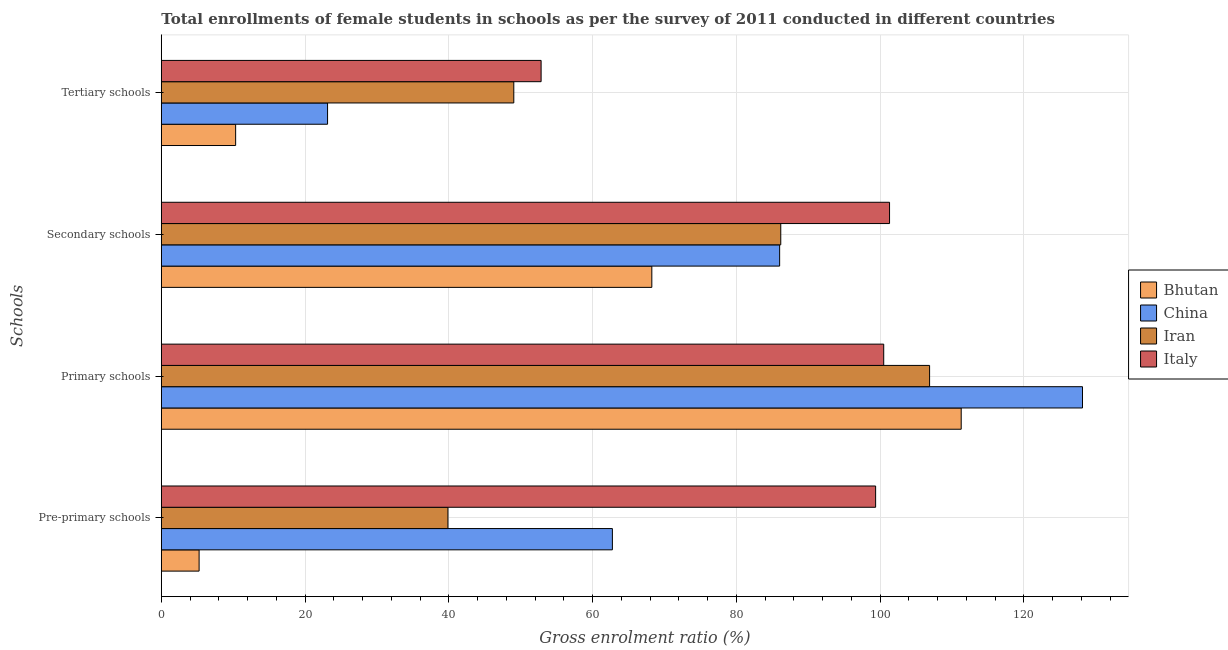Are the number of bars per tick equal to the number of legend labels?
Your response must be concise. Yes. Are the number of bars on each tick of the Y-axis equal?
Give a very brief answer. Yes. What is the label of the 4th group of bars from the top?
Keep it short and to the point. Pre-primary schools. What is the gross enrolment ratio(female) in primary schools in Bhutan?
Ensure brevity in your answer.  111.28. Across all countries, what is the maximum gross enrolment ratio(female) in tertiary schools?
Offer a terse response. 52.84. Across all countries, what is the minimum gross enrolment ratio(female) in primary schools?
Provide a short and direct response. 100.5. In which country was the gross enrolment ratio(female) in secondary schools maximum?
Offer a very short reply. Italy. In which country was the gross enrolment ratio(female) in secondary schools minimum?
Offer a very short reply. Bhutan. What is the total gross enrolment ratio(female) in secondary schools in the graph?
Make the answer very short. 341.76. What is the difference between the gross enrolment ratio(female) in tertiary schools in Iran and that in Bhutan?
Your answer should be very brief. 38.7. What is the difference between the gross enrolment ratio(female) in secondary schools in Iran and the gross enrolment ratio(female) in pre-primary schools in Italy?
Give a very brief answer. -13.2. What is the average gross enrolment ratio(female) in secondary schools per country?
Keep it short and to the point. 85.44. What is the difference between the gross enrolment ratio(female) in pre-primary schools and gross enrolment ratio(female) in primary schools in China?
Offer a terse response. -65.4. What is the ratio of the gross enrolment ratio(female) in pre-primary schools in China to that in Bhutan?
Ensure brevity in your answer.  11.93. Is the difference between the gross enrolment ratio(female) in secondary schools in China and Bhutan greater than the difference between the gross enrolment ratio(female) in pre-primary schools in China and Bhutan?
Provide a short and direct response. No. What is the difference between the highest and the second highest gross enrolment ratio(female) in pre-primary schools?
Ensure brevity in your answer.  36.62. What is the difference between the highest and the lowest gross enrolment ratio(female) in pre-primary schools?
Keep it short and to the point. 94.12. What does the 1st bar from the top in Tertiary schools represents?
Your answer should be very brief. Italy. What does the 1st bar from the bottom in Primary schools represents?
Provide a succinct answer. Bhutan. Is it the case that in every country, the sum of the gross enrolment ratio(female) in pre-primary schools and gross enrolment ratio(female) in primary schools is greater than the gross enrolment ratio(female) in secondary schools?
Ensure brevity in your answer.  Yes. How many bars are there?
Provide a succinct answer. 16. Are all the bars in the graph horizontal?
Keep it short and to the point. Yes. What is the difference between two consecutive major ticks on the X-axis?
Provide a succinct answer. 20. Are the values on the major ticks of X-axis written in scientific E-notation?
Provide a short and direct response. No. How many legend labels are there?
Your answer should be very brief. 4. What is the title of the graph?
Your answer should be very brief. Total enrollments of female students in schools as per the survey of 2011 conducted in different countries. What is the label or title of the X-axis?
Your answer should be very brief. Gross enrolment ratio (%). What is the label or title of the Y-axis?
Provide a short and direct response. Schools. What is the Gross enrolment ratio (%) in Bhutan in Pre-primary schools?
Give a very brief answer. 5.26. What is the Gross enrolment ratio (%) of China in Pre-primary schools?
Make the answer very short. 62.76. What is the Gross enrolment ratio (%) of Iran in Pre-primary schools?
Provide a succinct answer. 39.88. What is the Gross enrolment ratio (%) in Italy in Pre-primary schools?
Your response must be concise. 99.38. What is the Gross enrolment ratio (%) in Bhutan in Primary schools?
Make the answer very short. 111.28. What is the Gross enrolment ratio (%) of China in Primary schools?
Ensure brevity in your answer.  128.16. What is the Gross enrolment ratio (%) in Iran in Primary schools?
Ensure brevity in your answer.  106.89. What is the Gross enrolment ratio (%) of Italy in Primary schools?
Provide a succinct answer. 100.5. What is the Gross enrolment ratio (%) in Bhutan in Secondary schools?
Ensure brevity in your answer.  68.24. What is the Gross enrolment ratio (%) in China in Secondary schools?
Keep it short and to the point. 86.02. What is the Gross enrolment ratio (%) of Iran in Secondary schools?
Provide a succinct answer. 86.18. What is the Gross enrolment ratio (%) in Italy in Secondary schools?
Offer a terse response. 101.32. What is the Gross enrolment ratio (%) in Bhutan in Tertiary schools?
Provide a short and direct response. 10.34. What is the Gross enrolment ratio (%) in China in Tertiary schools?
Provide a succinct answer. 23.13. What is the Gross enrolment ratio (%) in Iran in Tertiary schools?
Give a very brief answer. 49.04. What is the Gross enrolment ratio (%) of Italy in Tertiary schools?
Keep it short and to the point. 52.84. Across all Schools, what is the maximum Gross enrolment ratio (%) of Bhutan?
Ensure brevity in your answer.  111.28. Across all Schools, what is the maximum Gross enrolment ratio (%) in China?
Keep it short and to the point. 128.16. Across all Schools, what is the maximum Gross enrolment ratio (%) of Iran?
Your response must be concise. 106.89. Across all Schools, what is the maximum Gross enrolment ratio (%) in Italy?
Your answer should be compact. 101.32. Across all Schools, what is the minimum Gross enrolment ratio (%) in Bhutan?
Keep it short and to the point. 5.26. Across all Schools, what is the minimum Gross enrolment ratio (%) in China?
Your response must be concise. 23.13. Across all Schools, what is the minimum Gross enrolment ratio (%) of Iran?
Offer a very short reply. 39.88. Across all Schools, what is the minimum Gross enrolment ratio (%) in Italy?
Make the answer very short. 52.84. What is the total Gross enrolment ratio (%) in Bhutan in the graph?
Your response must be concise. 195.12. What is the total Gross enrolment ratio (%) in China in the graph?
Offer a terse response. 300.07. What is the total Gross enrolment ratio (%) in Iran in the graph?
Make the answer very short. 281.98. What is the total Gross enrolment ratio (%) of Italy in the graph?
Your answer should be very brief. 354.03. What is the difference between the Gross enrolment ratio (%) of Bhutan in Pre-primary schools and that in Primary schools?
Ensure brevity in your answer.  -106.03. What is the difference between the Gross enrolment ratio (%) of China in Pre-primary schools and that in Primary schools?
Ensure brevity in your answer.  -65.4. What is the difference between the Gross enrolment ratio (%) of Iran in Pre-primary schools and that in Primary schools?
Your answer should be very brief. -67.01. What is the difference between the Gross enrolment ratio (%) in Italy in Pre-primary schools and that in Primary schools?
Provide a short and direct response. -1.12. What is the difference between the Gross enrolment ratio (%) in Bhutan in Pre-primary schools and that in Secondary schools?
Keep it short and to the point. -62.98. What is the difference between the Gross enrolment ratio (%) of China in Pre-primary schools and that in Secondary schools?
Ensure brevity in your answer.  -23.27. What is the difference between the Gross enrolment ratio (%) of Iran in Pre-primary schools and that in Secondary schools?
Give a very brief answer. -46.3. What is the difference between the Gross enrolment ratio (%) in Italy in Pre-primary schools and that in Secondary schools?
Your answer should be compact. -1.94. What is the difference between the Gross enrolment ratio (%) in Bhutan in Pre-primary schools and that in Tertiary schools?
Your response must be concise. -5.08. What is the difference between the Gross enrolment ratio (%) of China in Pre-primary schools and that in Tertiary schools?
Provide a succinct answer. 39.63. What is the difference between the Gross enrolment ratio (%) of Iran in Pre-primary schools and that in Tertiary schools?
Provide a short and direct response. -9.16. What is the difference between the Gross enrolment ratio (%) in Italy in Pre-primary schools and that in Tertiary schools?
Your response must be concise. 46.54. What is the difference between the Gross enrolment ratio (%) in Bhutan in Primary schools and that in Secondary schools?
Give a very brief answer. 43.04. What is the difference between the Gross enrolment ratio (%) in China in Primary schools and that in Secondary schools?
Ensure brevity in your answer.  42.13. What is the difference between the Gross enrolment ratio (%) of Iran in Primary schools and that in Secondary schools?
Offer a terse response. 20.7. What is the difference between the Gross enrolment ratio (%) in Italy in Primary schools and that in Secondary schools?
Ensure brevity in your answer.  -0.81. What is the difference between the Gross enrolment ratio (%) of Bhutan in Primary schools and that in Tertiary schools?
Your answer should be very brief. 100.94. What is the difference between the Gross enrolment ratio (%) of China in Primary schools and that in Tertiary schools?
Your answer should be compact. 105.03. What is the difference between the Gross enrolment ratio (%) of Iran in Primary schools and that in Tertiary schools?
Your answer should be compact. 57.85. What is the difference between the Gross enrolment ratio (%) in Italy in Primary schools and that in Tertiary schools?
Offer a terse response. 47.66. What is the difference between the Gross enrolment ratio (%) in Bhutan in Secondary schools and that in Tertiary schools?
Your answer should be compact. 57.9. What is the difference between the Gross enrolment ratio (%) in China in Secondary schools and that in Tertiary schools?
Give a very brief answer. 62.9. What is the difference between the Gross enrolment ratio (%) in Iran in Secondary schools and that in Tertiary schools?
Offer a terse response. 37.14. What is the difference between the Gross enrolment ratio (%) in Italy in Secondary schools and that in Tertiary schools?
Give a very brief answer. 48.48. What is the difference between the Gross enrolment ratio (%) of Bhutan in Pre-primary schools and the Gross enrolment ratio (%) of China in Primary schools?
Provide a succinct answer. -122.9. What is the difference between the Gross enrolment ratio (%) of Bhutan in Pre-primary schools and the Gross enrolment ratio (%) of Iran in Primary schools?
Ensure brevity in your answer.  -101.63. What is the difference between the Gross enrolment ratio (%) in Bhutan in Pre-primary schools and the Gross enrolment ratio (%) in Italy in Primary schools?
Ensure brevity in your answer.  -95.24. What is the difference between the Gross enrolment ratio (%) of China in Pre-primary schools and the Gross enrolment ratio (%) of Iran in Primary schools?
Give a very brief answer. -44.13. What is the difference between the Gross enrolment ratio (%) of China in Pre-primary schools and the Gross enrolment ratio (%) of Italy in Primary schools?
Offer a very short reply. -37.75. What is the difference between the Gross enrolment ratio (%) in Iran in Pre-primary schools and the Gross enrolment ratio (%) in Italy in Primary schools?
Your response must be concise. -60.63. What is the difference between the Gross enrolment ratio (%) in Bhutan in Pre-primary schools and the Gross enrolment ratio (%) in China in Secondary schools?
Offer a terse response. -80.77. What is the difference between the Gross enrolment ratio (%) of Bhutan in Pre-primary schools and the Gross enrolment ratio (%) of Iran in Secondary schools?
Keep it short and to the point. -80.92. What is the difference between the Gross enrolment ratio (%) in Bhutan in Pre-primary schools and the Gross enrolment ratio (%) in Italy in Secondary schools?
Provide a succinct answer. -96.06. What is the difference between the Gross enrolment ratio (%) of China in Pre-primary schools and the Gross enrolment ratio (%) of Iran in Secondary schools?
Keep it short and to the point. -23.43. What is the difference between the Gross enrolment ratio (%) in China in Pre-primary schools and the Gross enrolment ratio (%) in Italy in Secondary schools?
Ensure brevity in your answer.  -38.56. What is the difference between the Gross enrolment ratio (%) in Iran in Pre-primary schools and the Gross enrolment ratio (%) in Italy in Secondary schools?
Your answer should be compact. -61.44. What is the difference between the Gross enrolment ratio (%) of Bhutan in Pre-primary schools and the Gross enrolment ratio (%) of China in Tertiary schools?
Provide a short and direct response. -17.87. What is the difference between the Gross enrolment ratio (%) of Bhutan in Pre-primary schools and the Gross enrolment ratio (%) of Iran in Tertiary schools?
Offer a terse response. -43.78. What is the difference between the Gross enrolment ratio (%) of Bhutan in Pre-primary schools and the Gross enrolment ratio (%) of Italy in Tertiary schools?
Offer a very short reply. -47.58. What is the difference between the Gross enrolment ratio (%) in China in Pre-primary schools and the Gross enrolment ratio (%) in Iran in Tertiary schools?
Your answer should be compact. 13.72. What is the difference between the Gross enrolment ratio (%) of China in Pre-primary schools and the Gross enrolment ratio (%) of Italy in Tertiary schools?
Offer a very short reply. 9.92. What is the difference between the Gross enrolment ratio (%) in Iran in Pre-primary schools and the Gross enrolment ratio (%) in Italy in Tertiary schools?
Ensure brevity in your answer.  -12.96. What is the difference between the Gross enrolment ratio (%) of Bhutan in Primary schools and the Gross enrolment ratio (%) of China in Secondary schools?
Your answer should be compact. 25.26. What is the difference between the Gross enrolment ratio (%) of Bhutan in Primary schools and the Gross enrolment ratio (%) of Iran in Secondary schools?
Provide a short and direct response. 25.1. What is the difference between the Gross enrolment ratio (%) of Bhutan in Primary schools and the Gross enrolment ratio (%) of Italy in Secondary schools?
Ensure brevity in your answer.  9.97. What is the difference between the Gross enrolment ratio (%) of China in Primary schools and the Gross enrolment ratio (%) of Iran in Secondary schools?
Keep it short and to the point. 41.98. What is the difference between the Gross enrolment ratio (%) in China in Primary schools and the Gross enrolment ratio (%) in Italy in Secondary schools?
Provide a short and direct response. 26.84. What is the difference between the Gross enrolment ratio (%) in Iran in Primary schools and the Gross enrolment ratio (%) in Italy in Secondary schools?
Provide a succinct answer. 5.57. What is the difference between the Gross enrolment ratio (%) of Bhutan in Primary schools and the Gross enrolment ratio (%) of China in Tertiary schools?
Ensure brevity in your answer.  88.16. What is the difference between the Gross enrolment ratio (%) in Bhutan in Primary schools and the Gross enrolment ratio (%) in Iran in Tertiary schools?
Keep it short and to the point. 62.25. What is the difference between the Gross enrolment ratio (%) in Bhutan in Primary schools and the Gross enrolment ratio (%) in Italy in Tertiary schools?
Make the answer very short. 58.45. What is the difference between the Gross enrolment ratio (%) in China in Primary schools and the Gross enrolment ratio (%) in Iran in Tertiary schools?
Provide a succinct answer. 79.12. What is the difference between the Gross enrolment ratio (%) in China in Primary schools and the Gross enrolment ratio (%) in Italy in Tertiary schools?
Keep it short and to the point. 75.32. What is the difference between the Gross enrolment ratio (%) in Iran in Primary schools and the Gross enrolment ratio (%) in Italy in Tertiary schools?
Your response must be concise. 54.05. What is the difference between the Gross enrolment ratio (%) of Bhutan in Secondary schools and the Gross enrolment ratio (%) of China in Tertiary schools?
Your answer should be compact. 45.11. What is the difference between the Gross enrolment ratio (%) of Bhutan in Secondary schools and the Gross enrolment ratio (%) of Iran in Tertiary schools?
Ensure brevity in your answer.  19.2. What is the difference between the Gross enrolment ratio (%) of Bhutan in Secondary schools and the Gross enrolment ratio (%) of Italy in Tertiary schools?
Your answer should be compact. 15.4. What is the difference between the Gross enrolment ratio (%) of China in Secondary schools and the Gross enrolment ratio (%) of Iran in Tertiary schools?
Make the answer very short. 36.99. What is the difference between the Gross enrolment ratio (%) of China in Secondary schools and the Gross enrolment ratio (%) of Italy in Tertiary schools?
Your answer should be very brief. 33.19. What is the difference between the Gross enrolment ratio (%) of Iran in Secondary schools and the Gross enrolment ratio (%) of Italy in Tertiary schools?
Keep it short and to the point. 33.34. What is the average Gross enrolment ratio (%) in Bhutan per Schools?
Ensure brevity in your answer.  48.78. What is the average Gross enrolment ratio (%) of China per Schools?
Provide a short and direct response. 75.02. What is the average Gross enrolment ratio (%) of Iran per Schools?
Keep it short and to the point. 70.5. What is the average Gross enrolment ratio (%) in Italy per Schools?
Your answer should be compact. 88.51. What is the difference between the Gross enrolment ratio (%) of Bhutan and Gross enrolment ratio (%) of China in Pre-primary schools?
Offer a very short reply. -57.5. What is the difference between the Gross enrolment ratio (%) of Bhutan and Gross enrolment ratio (%) of Iran in Pre-primary schools?
Make the answer very short. -34.62. What is the difference between the Gross enrolment ratio (%) of Bhutan and Gross enrolment ratio (%) of Italy in Pre-primary schools?
Offer a terse response. -94.12. What is the difference between the Gross enrolment ratio (%) in China and Gross enrolment ratio (%) in Iran in Pre-primary schools?
Offer a very short reply. 22.88. What is the difference between the Gross enrolment ratio (%) of China and Gross enrolment ratio (%) of Italy in Pre-primary schools?
Your answer should be compact. -36.62. What is the difference between the Gross enrolment ratio (%) of Iran and Gross enrolment ratio (%) of Italy in Pre-primary schools?
Offer a terse response. -59.5. What is the difference between the Gross enrolment ratio (%) of Bhutan and Gross enrolment ratio (%) of China in Primary schools?
Offer a very short reply. -16.87. What is the difference between the Gross enrolment ratio (%) in Bhutan and Gross enrolment ratio (%) in Iran in Primary schools?
Provide a succinct answer. 4.4. What is the difference between the Gross enrolment ratio (%) of Bhutan and Gross enrolment ratio (%) of Italy in Primary schools?
Your answer should be very brief. 10.78. What is the difference between the Gross enrolment ratio (%) in China and Gross enrolment ratio (%) in Iran in Primary schools?
Offer a terse response. 21.27. What is the difference between the Gross enrolment ratio (%) in China and Gross enrolment ratio (%) in Italy in Primary schools?
Your answer should be very brief. 27.66. What is the difference between the Gross enrolment ratio (%) of Iran and Gross enrolment ratio (%) of Italy in Primary schools?
Offer a very short reply. 6.38. What is the difference between the Gross enrolment ratio (%) of Bhutan and Gross enrolment ratio (%) of China in Secondary schools?
Offer a terse response. -17.78. What is the difference between the Gross enrolment ratio (%) in Bhutan and Gross enrolment ratio (%) in Iran in Secondary schools?
Offer a very short reply. -17.94. What is the difference between the Gross enrolment ratio (%) in Bhutan and Gross enrolment ratio (%) in Italy in Secondary schools?
Make the answer very short. -33.07. What is the difference between the Gross enrolment ratio (%) in China and Gross enrolment ratio (%) in Iran in Secondary schools?
Make the answer very short. -0.16. What is the difference between the Gross enrolment ratio (%) of China and Gross enrolment ratio (%) of Italy in Secondary schools?
Ensure brevity in your answer.  -15.29. What is the difference between the Gross enrolment ratio (%) in Iran and Gross enrolment ratio (%) in Italy in Secondary schools?
Provide a succinct answer. -15.13. What is the difference between the Gross enrolment ratio (%) in Bhutan and Gross enrolment ratio (%) in China in Tertiary schools?
Make the answer very short. -12.79. What is the difference between the Gross enrolment ratio (%) of Bhutan and Gross enrolment ratio (%) of Iran in Tertiary schools?
Your answer should be compact. -38.7. What is the difference between the Gross enrolment ratio (%) of Bhutan and Gross enrolment ratio (%) of Italy in Tertiary schools?
Ensure brevity in your answer.  -42.5. What is the difference between the Gross enrolment ratio (%) in China and Gross enrolment ratio (%) in Iran in Tertiary schools?
Your answer should be very brief. -25.91. What is the difference between the Gross enrolment ratio (%) of China and Gross enrolment ratio (%) of Italy in Tertiary schools?
Your answer should be very brief. -29.71. What is the difference between the Gross enrolment ratio (%) in Iran and Gross enrolment ratio (%) in Italy in Tertiary schools?
Keep it short and to the point. -3.8. What is the ratio of the Gross enrolment ratio (%) in Bhutan in Pre-primary schools to that in Primary schools?
Provide a succinct answer. 0.05. What is the ratio of the Gross enrolment ratio (%) in China in Pre-primary schools to that in Primary schools?
Make the answer very short. 0.49. What is the ratio of the Gross enrolment ratio (%) in Iran in Pre-primary schools to that in Primary schools?
Offer a very short reply. 0.37. What is the ratio of the Gross enrolment ratio (%) in Italy in Pre-primary schools to that in Primary schools?
Your response must be concise. 0.99. What is the ratio of the Gross enrolment ratio (%) in Bhutan in Pre-primary schools to that in Secondary schools?
Provide a succinct answer. 0.08. What is the ratio of the Gross enrolment ratio (%) of China in Pre-primary schools to that in Secondary schools?
Keep it short and to the point. 0.73. What is the ratio of the Gross enrolment ratio (%) in Iran in Pre-primary schools to that in Secondary schools?
Ensure brevity in your answer.  0.46. What is the ratio of the Gross enrolment ratio (%) in Italy in Pre-primary schools to that in Secondary schools?
Your answer should be compact. 0.98. What is the ratio of the Gross enrolment ratio (%) of Bhutan in Pre-primary schools to that in Tertiary schools?
Your response must be concise. 0.51. What is the ratio of the Gross enrolment ratio (%) of China in Pre-primary schools to that in Tertiary schools?
Offer a very short reply. 2.71. What is the ratio of the Gross enrolment ratio (%) in Iran in Pre-primary schools to that in Tertiary schools?
Make the answer very short. 0.81. What is the ratio of the Gross enrolment ratio (%) of Italy in Pre-primary schools to that in Tertiary schools?
Provide a short and direct response. 1.88. What is the ratio of the Gross enrolment ratio (%) of Bhutan in Primary schools to that in Secondary schools?
Your answer should be compact. 1.63. What is the ratio of the Gross enrolment ratio (%) of China in Primary schools to that in Secondary schools?
Ensure brevity in your answer.  1.49. What is the ratio of the Gross enrolment ratio (%) of Iran in Primary schools to that in Secondary schools?
Ensure brevity in your answer.  1.24. What is the ratio of the Gross enrolment ratio (%) of Italy in Primary schools to that in Secondary schools?
Ensure brevity in your answer.  0.99. What is the ratio of the Gross enrolment ratio (%) of Bhutan in Primary schools to that in Tertiary schools?
Make the answer very short. 10.76. What is the ratio of the Gross enrolment ratio (%) of China in Primary schools to that in Tertiary schools?
Your answer should be very brief. 5.54. What is the ratio of the Gross enrolment ratio (%) of Iran in Primary schools to that in Tertiary schools?
Provide a succinct answer. 2.18. What is the ratio of the Gross enrolment ratio (%) of Italy in Primary schools to that in Tertiary schools?
Offer a very short reply. 1.9. What is the ratio of the Gross enrolment ratio (%) of Bhutan in Secondary schools to that in Tertiary schools?
Your answer should be very brief. 6.6. What is the ratio of the Gross enrolment ratio (%) in China in Secondary schools to that in Tertiary schools?
Provide a succinct answer. 3.72. What is the ratio of the Gross enrolment ratio (%) in Iran in Secondary schools to that in Tertiary schools?
Provide a succinct answer. 1.76. What is the ratio of the Gross enrolment ratio (%) in Italy in Secondary schools to that in Tertiary schools?
Offer a very short reply. 1.92. What is the difference between the highest and the second highest Gross enrolment ratio (%) in Bhutan?
Give a very brief answer. 43.04. What is the difference between the highest and the second highest Gross enrolment ratio (%) of China?
Provide a short and direct response. 42.13. What is the difference between the highest and the second highest Gross enrolment ratio (%) of Iran?
Provide a short and direct response. 20.7. What is the difference between the highest and the second highest Gross enrolment ratio (%) in Italy?
Your response must be concise. 0.81. What is the difference between the highest and the lowest Gross enrolment ratio (%) in Bhutan?
Your answer should be very brief. 106.03. What is the difference between the highest and the lowest Gross enrolment ratio (%) in China?
Your answer should be very brief. 105.03. What is the difference between the highest and the lowest Gross enrolment ratio (%) of Iran?
Your response must be concise. 67.01. What is the difference between the highest and the lowest Gross enrolment ratio (%) in Italy?
Make the answer very short. 48.48. 